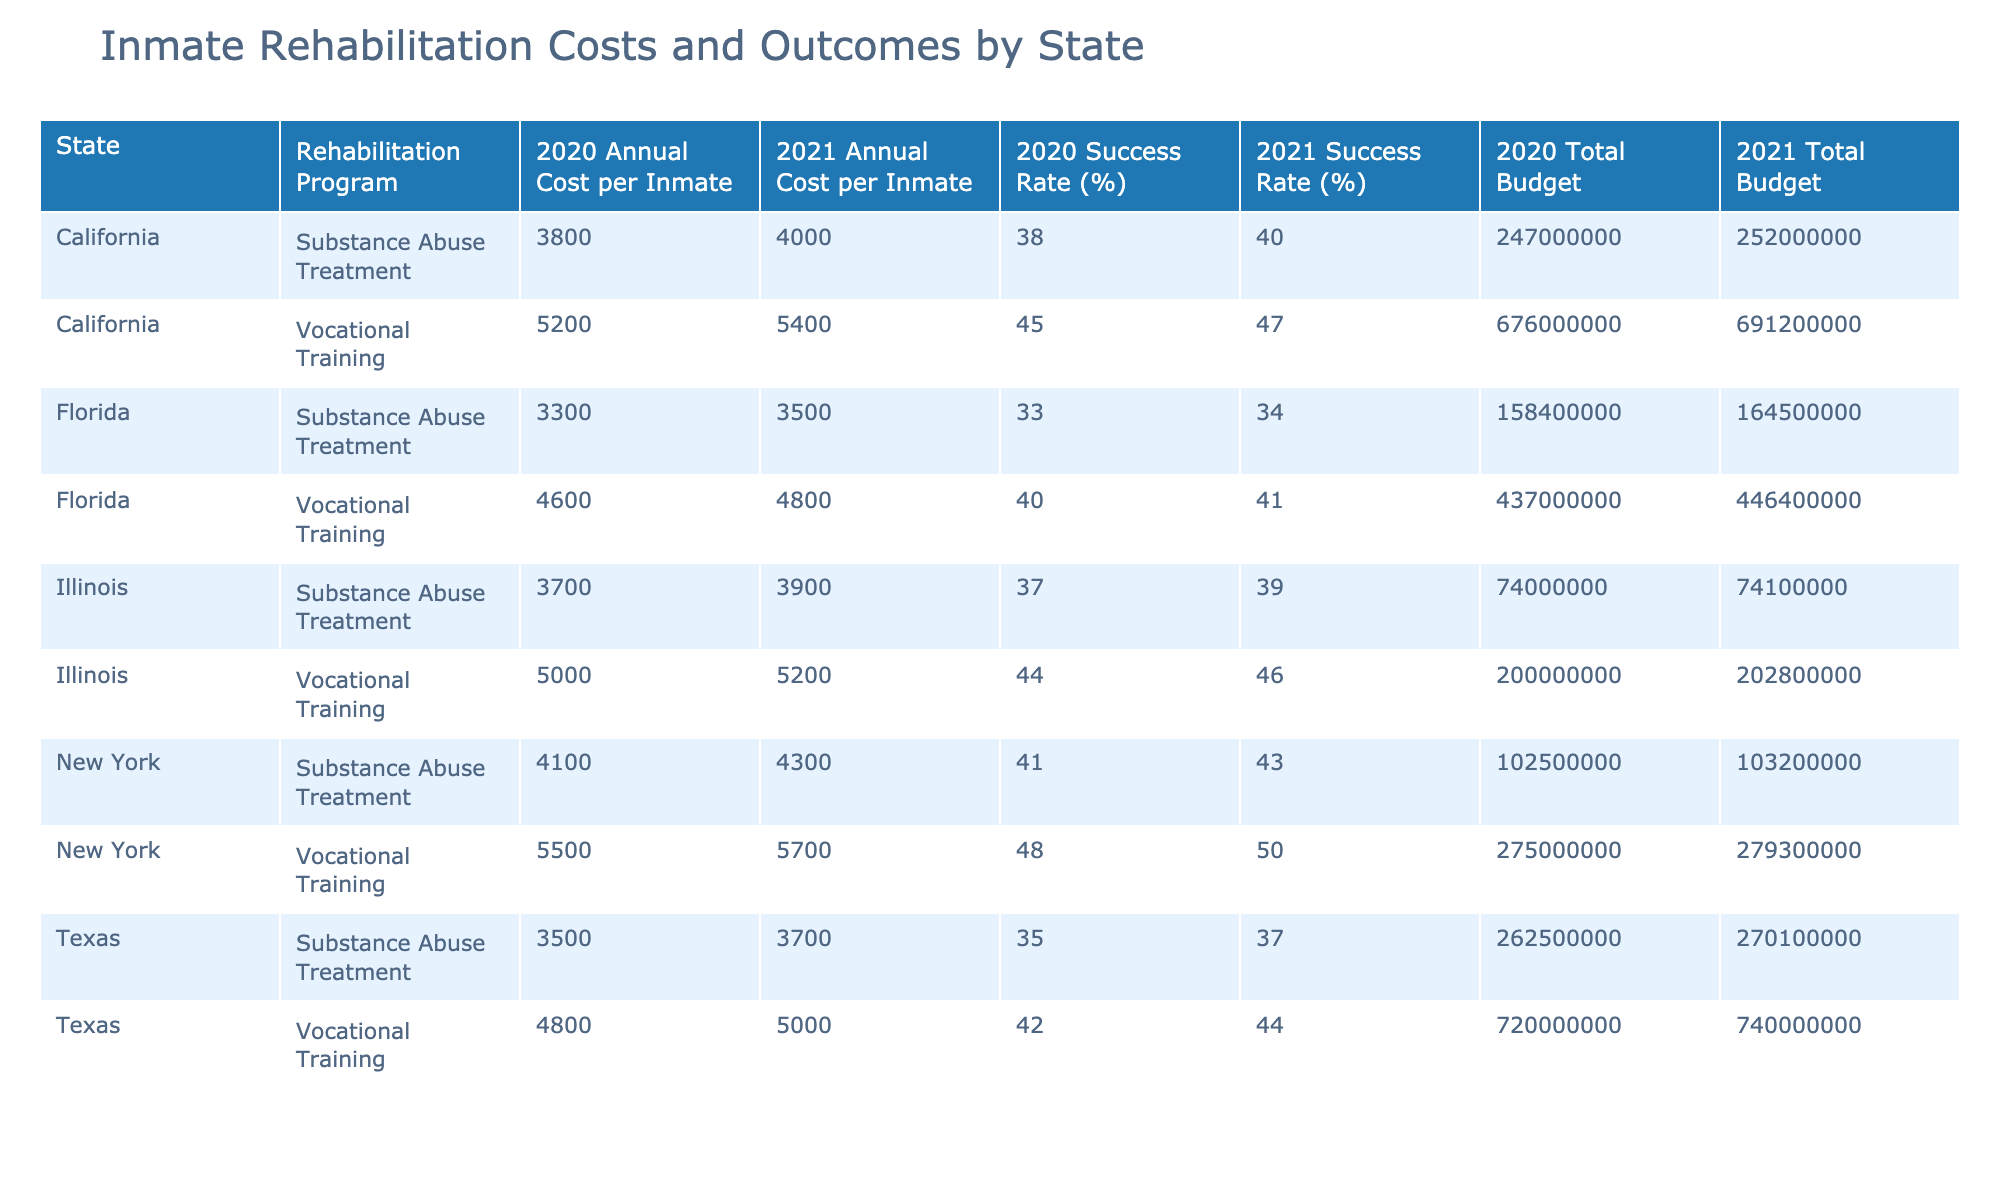What is the annual cost per inmate for Vocational Training in Florida in 2021? The table shows the value for Vocational Training in Florida for the year 2021, which is listed under the column for 'Annual Cost per Inmate'. The value found is 4800.
Answer: 4800 Which state had the highest success rate for Substance Abuse Treatment in 2020? In the table, I look at the success rates for Substance Abuse Treatment in 2020 across all states. The rates are 38 for California, 35 for Texas, 33 for Florida, and 41 for New York. The highest is 41, which belongs to New York.
Answer: New York What is the average annual cost per inmate for Vocational Training across all states in 2020? To find the average annual cost per inmate for Vocational Training, I identify the costs for the year 2020: California (5200), Texas (4800), Florida (4600), New York (5500), and Illinois (5000). I sum these values: 5200 + 4800 + 4600 + 5500 + 5000 = 25100. There are 5 states, so the average is 25100 / 5 = 5020.
Answer: 5020 Does Illinois have a higher total budget for Rehabilitation Programs in 2021 than Texas? The totals for the budgets in 2021 are 202800000 for Illinois and 740000000 for Texas. Since 202800000 is less than 740000000, the statement is false.
Answer: No What is the difference in the annual cost per inmate for Substance Abuse Treatment between California and Texas in 2021? The annual costs for 2021 are 4000 for California and 3700 for Texas under Substance Abuse Treatment. The difference is calculated by subtracting Texas cost from California cost: 4000 - 3700 = 300.
Answer: 300 What was the total number of inmates in New York for 2020 and 2021 across all rehabilitation programs? From the table, New York had 50000 inmates in 2020 and 49000 in 2021. I add these values together: 50000 + 49000 = 99000.
Answer: 99000 Which rehabilitation program in Illinois had a higher success rate in 2021? The success rates in Illinois for 2021 are 46% for Vocational Training and 39% for Substance Abuse Treatment. Comparing these values, 46% is greater than 39%, indicating Vocational Training had a higher success rate.
Answer: Vocational Training Was the annual cost per inmate for Substance Abuse Treatment in Texas lower in 2020 than in Florida? The cost in Texas for 2020 was 3500, while in Florida, it was 3300. Since 3500 is greater than 3300, the statement is false.
Answer: No 